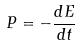<formula> <loc_0><loc_0><loc_500><loc_500>P = - \frac { d E } { d t }</formula> 